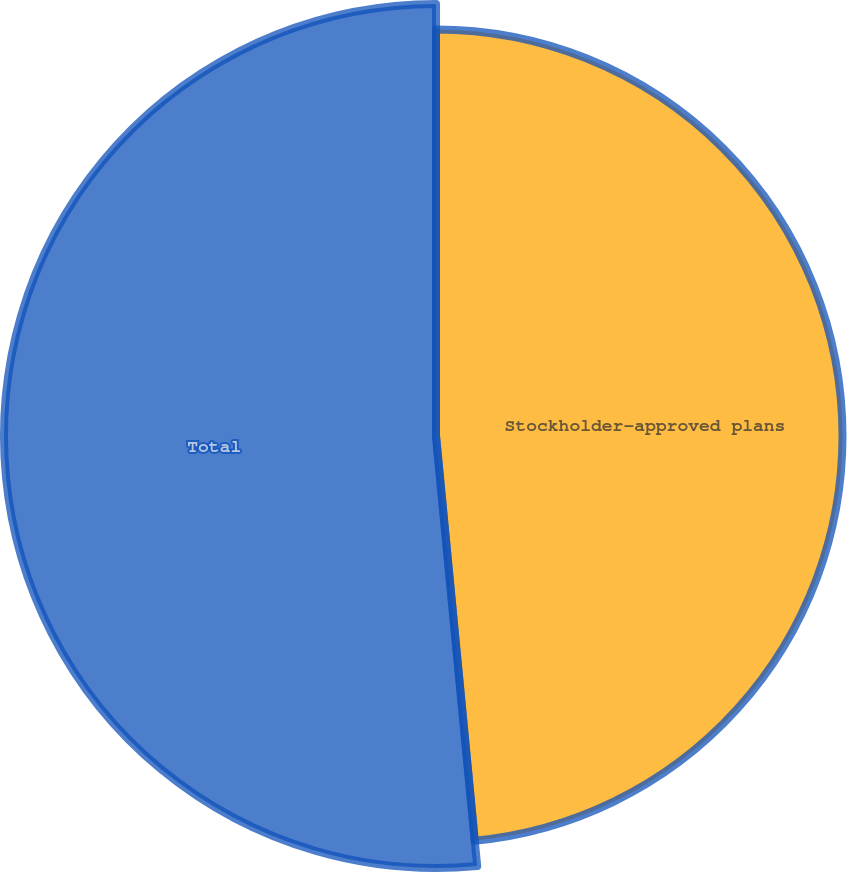<chart> <loc_0><loc_0><loc_500><loc_500><pie_chart><fcel>Stockholder-approved plans<fcel>Total<nl><fcel>48.48%<fcel>51.52%<nl></chart> 